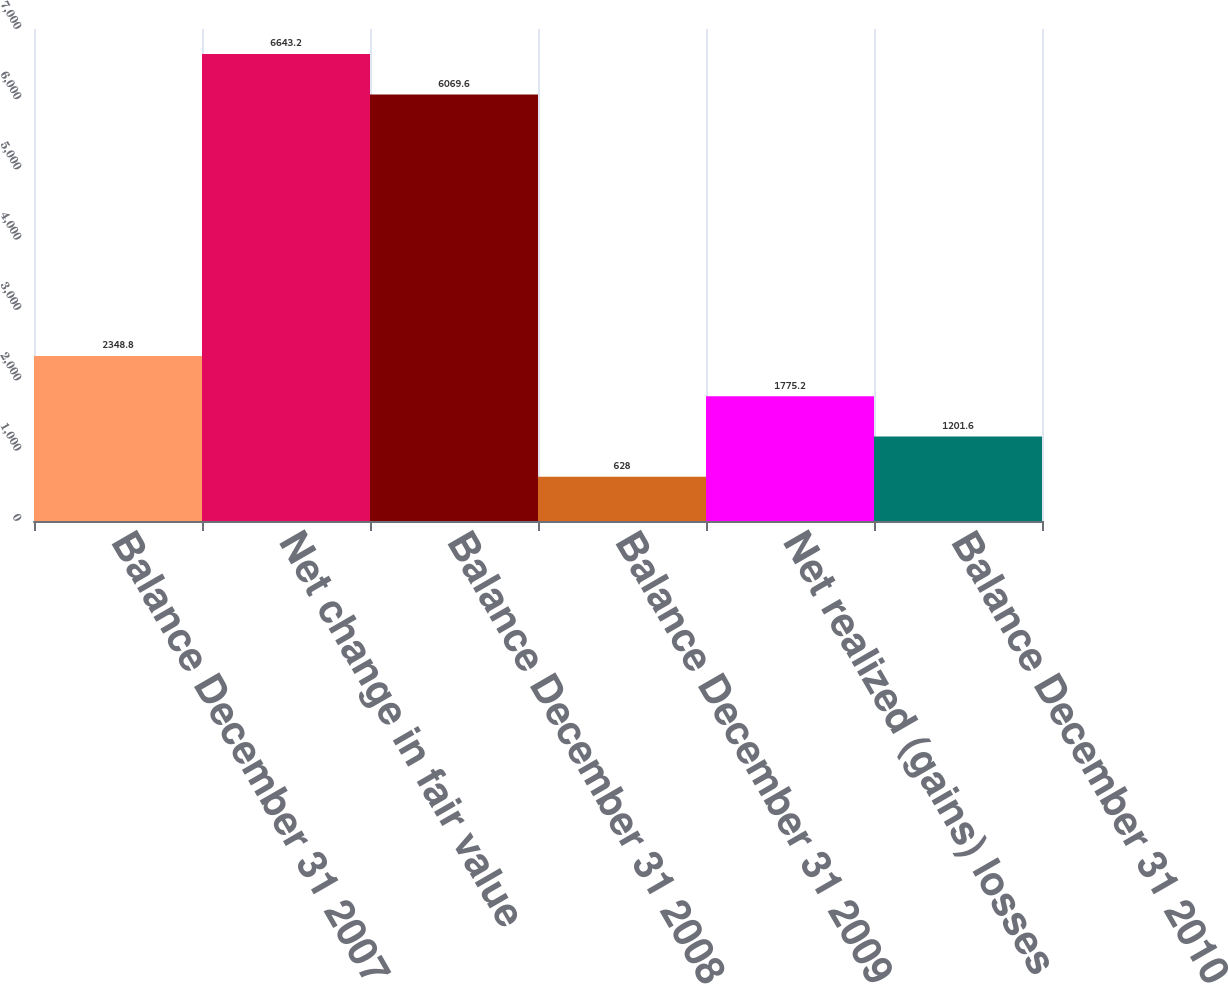Convert chart to OTSL. <chart><loc_0><loc_0><loc_500><loc_500><bar_chart><fcel>Balance December 31 2007<fcel>Net change in fair value<fcel>Balance December 31 2008<fcel>Balance December 31 2009<fcel>Net realized (gains) losses<fcel>Balance December 31 2010<nl><fcel>2348.8<fcel>6643.2<fcel>6069.6<fcel>628<fcel>1775.2<fcel>1201.6<nl></chart> 